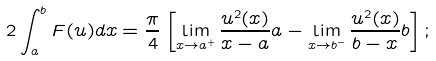<formula> <loc_0><loc_0><loc_500><loc_500>2 \int _ { a } ^ { b } F ( u ) d x = \frac { \pi } { 4 } \left [ \lim _ { x \to a ^ { + } } \frac { u ^ { 2 } ( x ) } { x - a } a - \lim _ { x \to b ^ { - } } \frac { u ^ { 2 } ( x ) } { b - x } b \right ] ;</formula> 